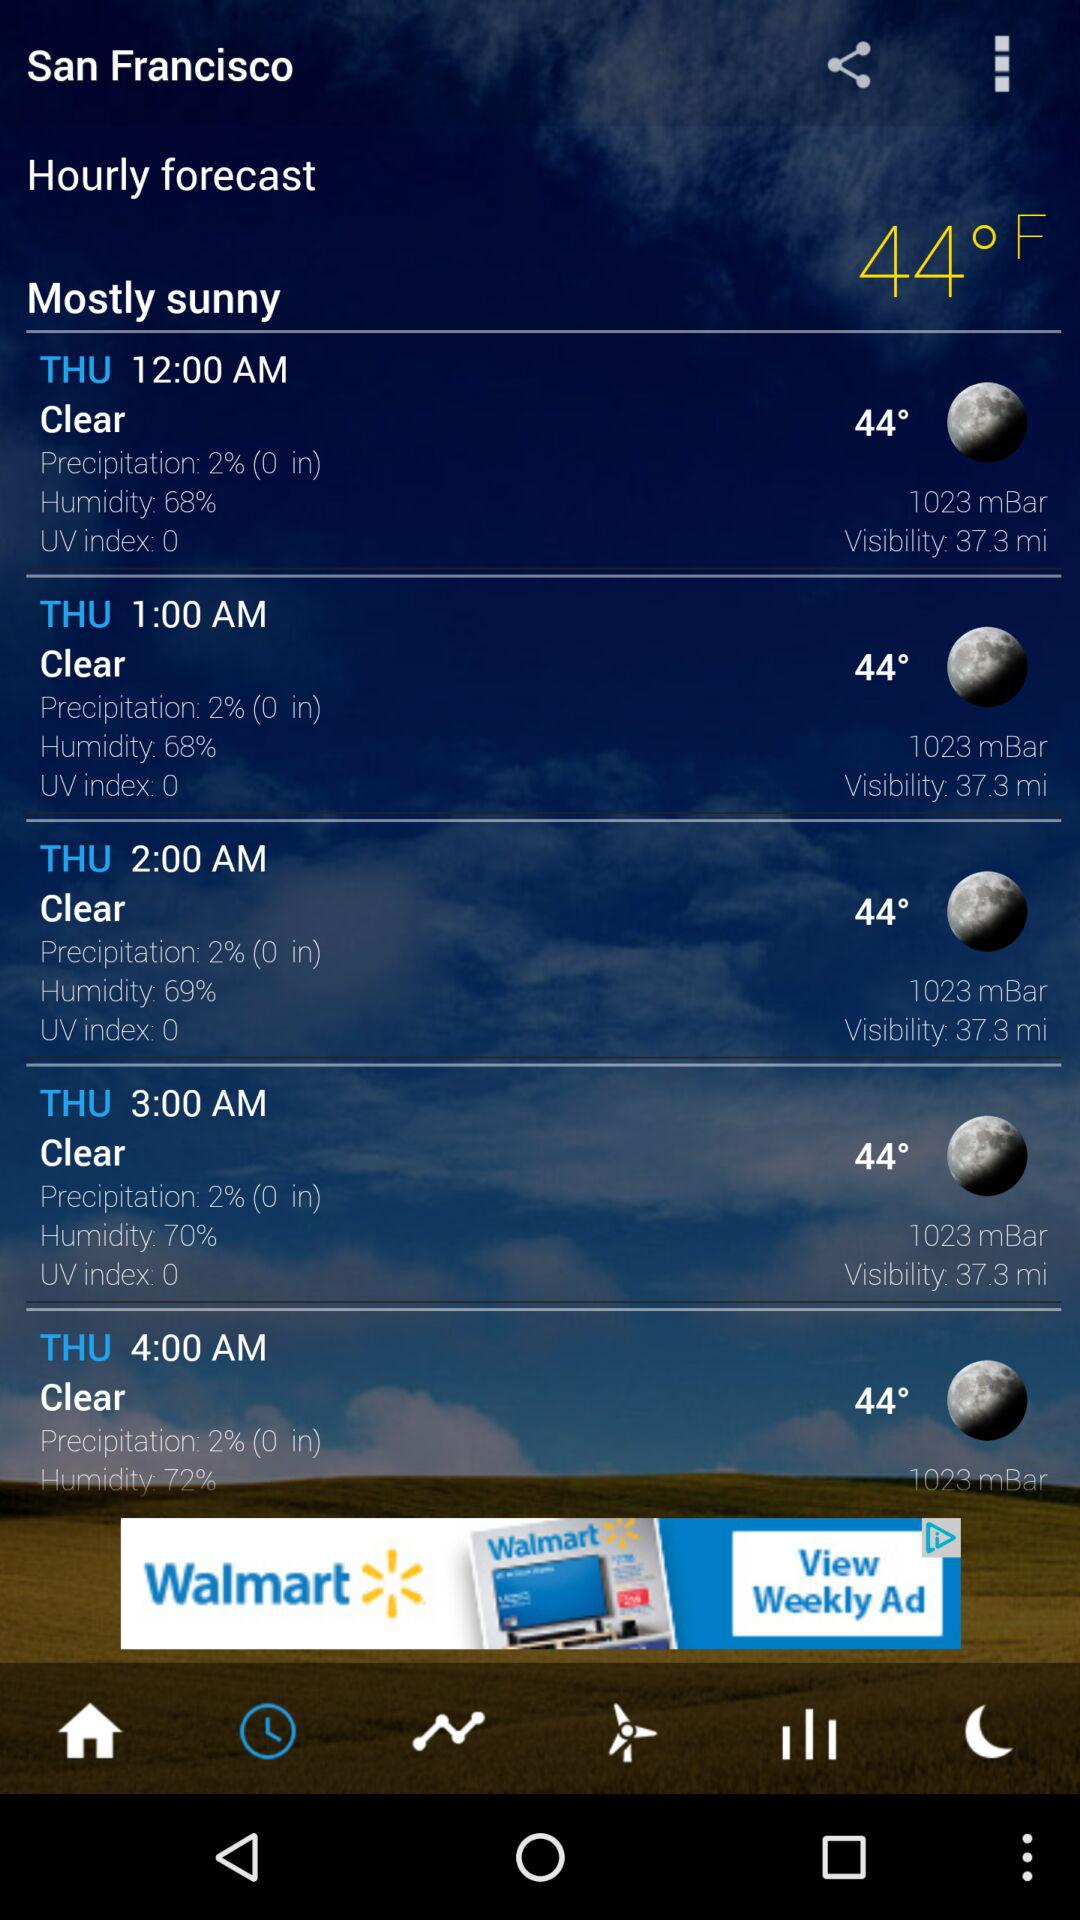What is the day? The day is Thursday. 